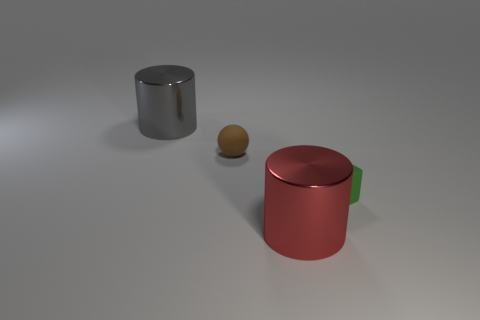What is the color of the cylinder in front of the gray shiny cylinder?
Offer a very short reply. Red. What is the object that is to the left of the large red metal thing and on the right side of the gray cylinder made of?
Keep it short and to the point. Rubber. What shape is the brown object that is made of the same material as the green cube?
Offer a terse response. Sphere. There is a cylinder in front of the small green rubber object; how many tiny green blocks are left of it?
Your answer should be very brief. 0. What number of shiny things are right of the large gray cylinder and behind the big red shiny object?
Ensure brevity in your answer.  0. How many other things are there of the same material as the red thing?
Your answer should be very brief. 1. What is the color of the metal cylinder that is on the left side of the cylinder that is in front of the big gray cylinder?
Provide a succinct answer. Gray. Does the large metallic thing behind the large red shiny cylinder have the same color as the small rubber block?
Keep it short and to the point. No. Is the red metallic cylinder the same size as the rubber ball?
Give a very brief answer. No. What is the shape of the other metallic object that is the same size as the red metal object?
Provide a succinct answer. Cylinder. 